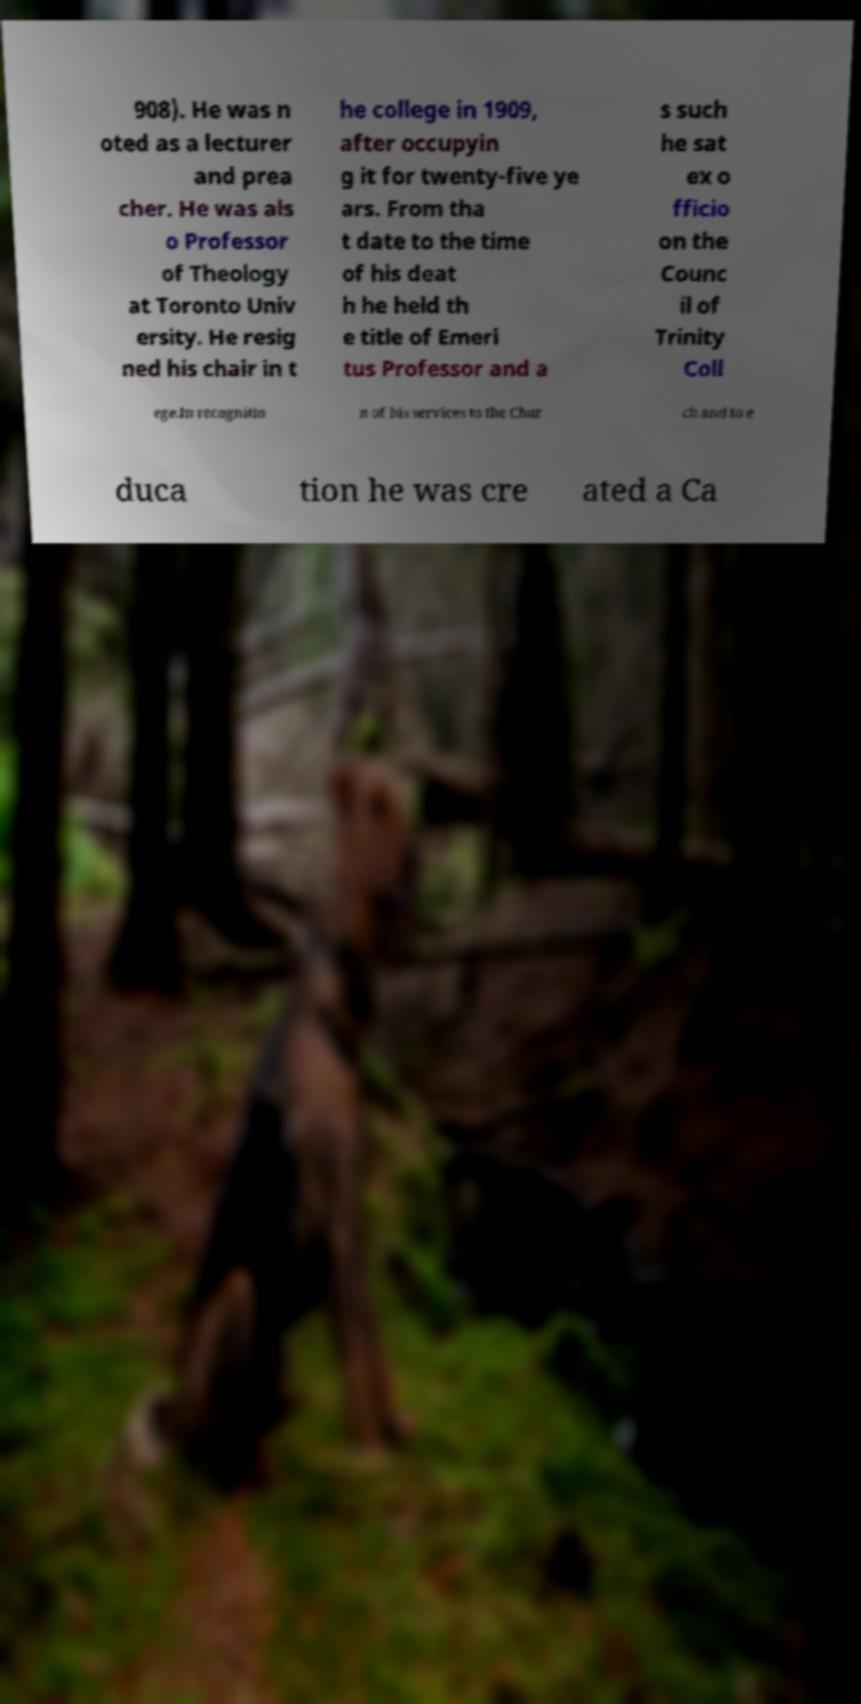Can you accurately transcribe the text from the provided image for me? 908). He was n oted as a lecturer and prea cher. He was als o Professor of Theology at Toronto Univ ersity. He resig ned his chair in t he college in 1909, after occupyin g it for twenty-five ye ars. From tha t date to the time of his deat h he held th e title of Emeri tus Professor and a s such he sat ex o fficio on the Counc il of Trinity Coll ege.In recognitio n of his services to the Chur ch and to e duca tion he was cre ated a Ca 